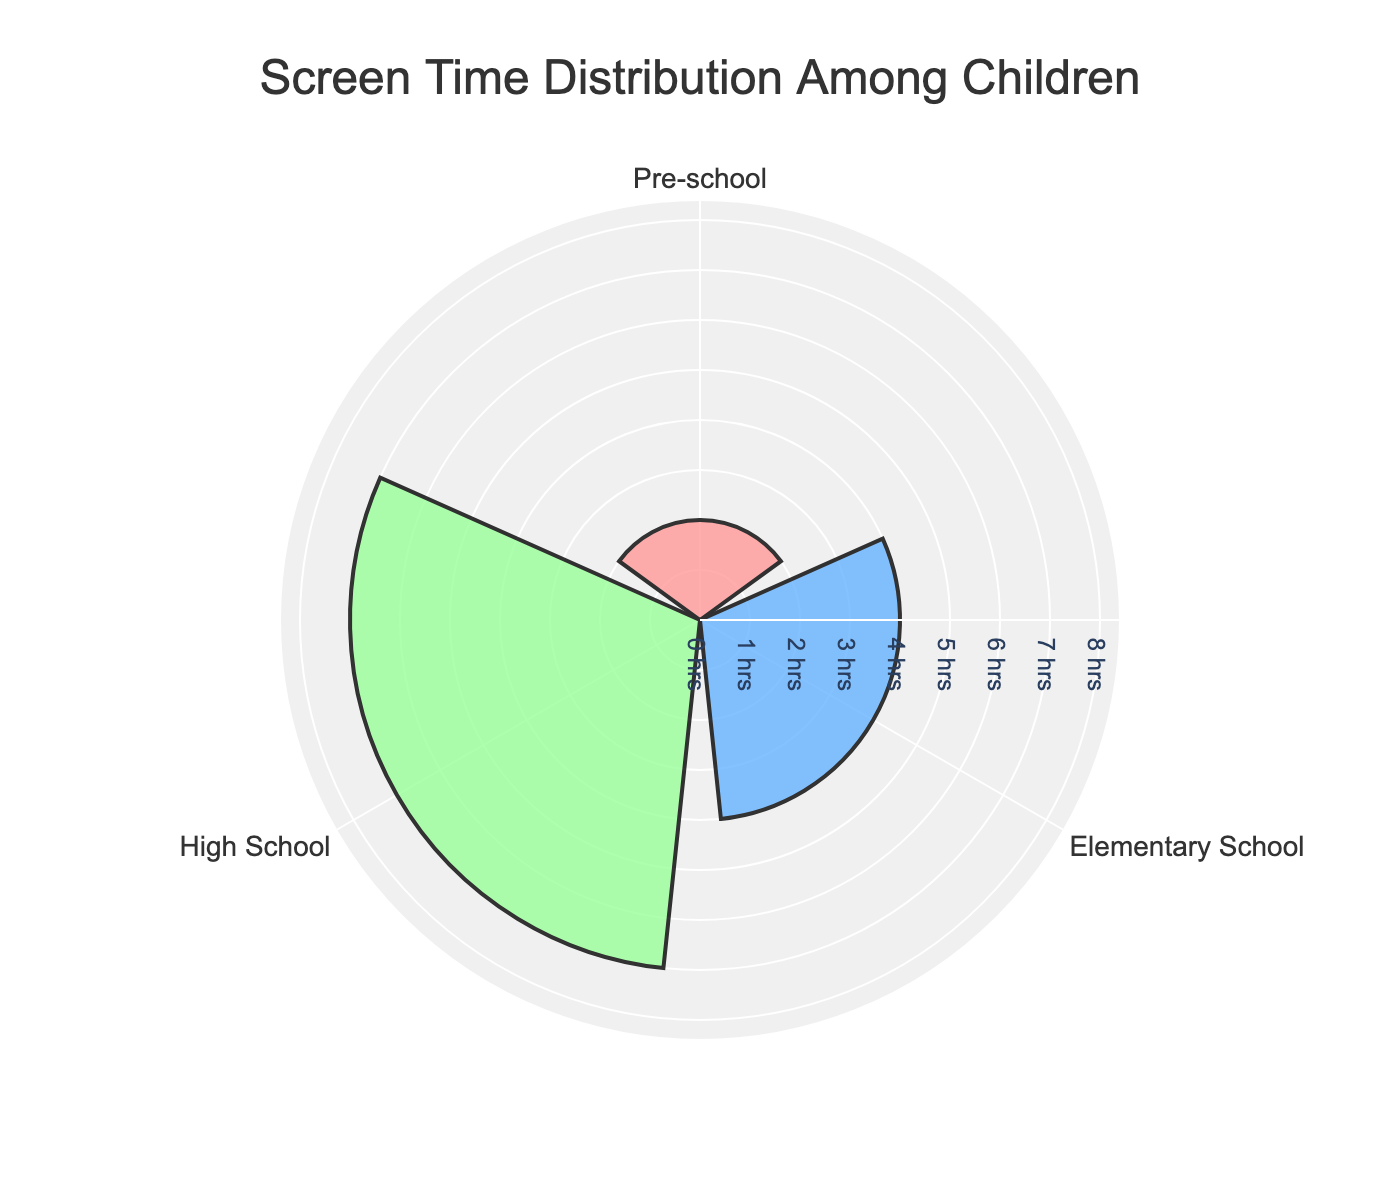What's the title of the figure? The title is a text element usually placed at the top of the figure, and it summarizes the main point of the chart. For this figure, the title is "Screen Time Distribution Among Children" as it clearly indicates what the chart is about.
Answer: Screen Time Distribution Among Children Which age group has the highest average daily screen time? To find this, look at the bars extending out from the center of the plot. The bar with the greatest length corresponds to the age group with the highest screen time. In this figure, the High School group has the longest bar, indicating the highest average daily screen time.
Answer: High School What are the colors used for the different age groups? Each age group is represented by a different color on the chart. By identifying and matching the colors in the figure, we see that Pre-school is pink (#FF9999), Elementary School is blue (#66B2FF), and High School is green (#99FF99).
Answer: Pink for Pre-school, Blue for Elementary School, Green for High School How much more screen time do High School students have compared to Elementary School students? To determine this, subtract the average screen time of Elementary School students from the average screen time of High School students. For High School, it's 7 hours and for Elementary School, it's 4 hours. So, 7 - 4 equals 3 hours more.
Answer: 3 hours more What is the median screen time across all age groups? Since there are three data points (2, 4, 7 hours for Pre-school, Elementary School, and High School respectively), the median is the middle value in an ordered list, which is 4 hours.
Answer: 4 hours Which age group has the lowest average daily screen time? The age group with the shortest bar on the plot has the lowest average daily screen time. In this figure, the Pre-school group has the shortest bar, meaning it has the lowest screen time.
Answer: Pre-school What's the sum of the average daily screen times for all three age groups? Add up the average daily screen times of all age groups: 2 hours (Pre-school) + 4 hours (Elementary School) + 7 hours (High School) = 13 hours.
Answer: 13 hours How is the data distributed among the age groups? The data is distributed with increasing screen time as we move from younger to older age groups: Pre-school has 2 hours, Elementary School has 4 hours, and High School has 7 hours of average daily screen time. This shows a trend of increasing screen time with age.
Answer: Increasing with age 